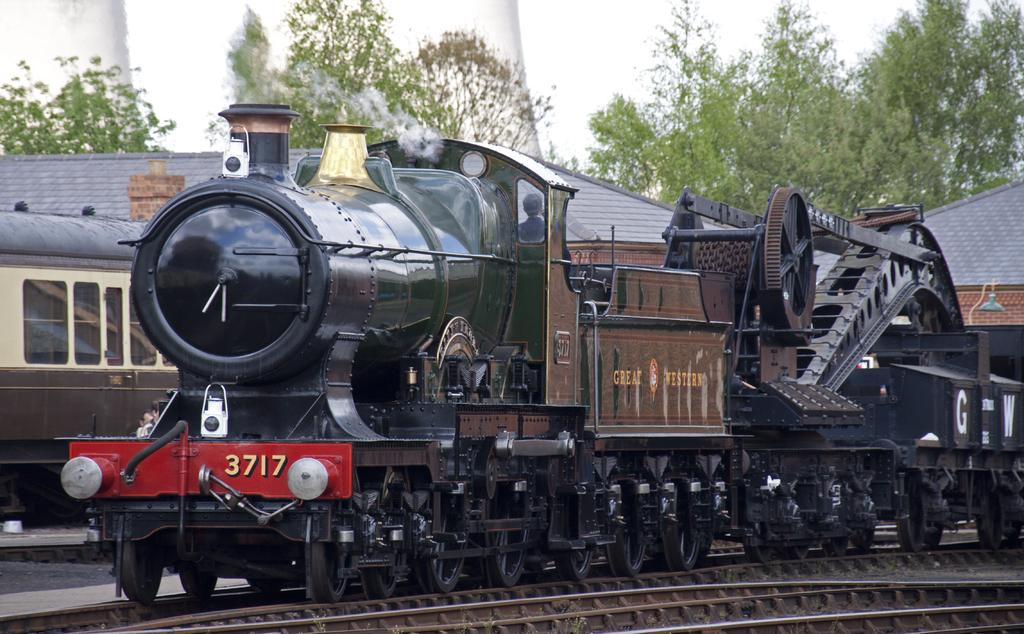What is present on the railway tracks in the image? There are trains on the railway tracks in the image. What can be seen in the distance behind the trains? There are buildings, trees, and the sky visible in the background of the image. What type of oil is being used by the committee in the image? There is no committee or oil present in the image; it features trains on railway tracks with buildings, trees, and the sky in the background. 